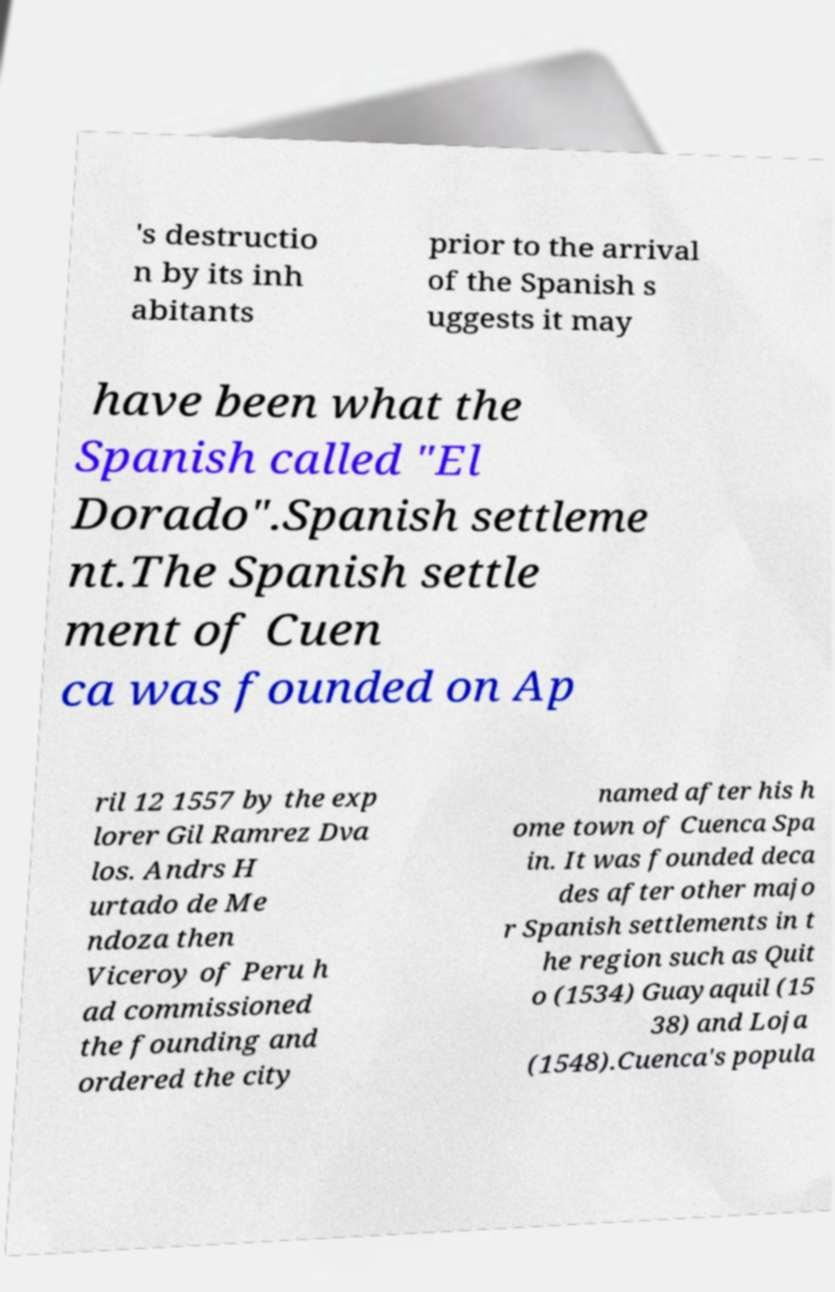Could you extract and type out the text from this image? 's destructio n by its inh abitants prior to the arrival of the Spanish s uggests it may have been what the Spanish called "El Dorado".Spanish settleme nt.The Spanish settle ment of Cuen ca was founded on Ap ril 12 1557 by the exp lorer Gil Ramrez Dva los. Andrs H urtado de Me ndoza then Viceroy of Peru h ad commissioned the founding and ordered the city named after his h ome town of Cuenca Spa in. It was founded deca des after other majo r Spanish settlements in t he region such as Quit o (1534) Guayaquil (15 38) and Loja (1548).Cuenca's popula 